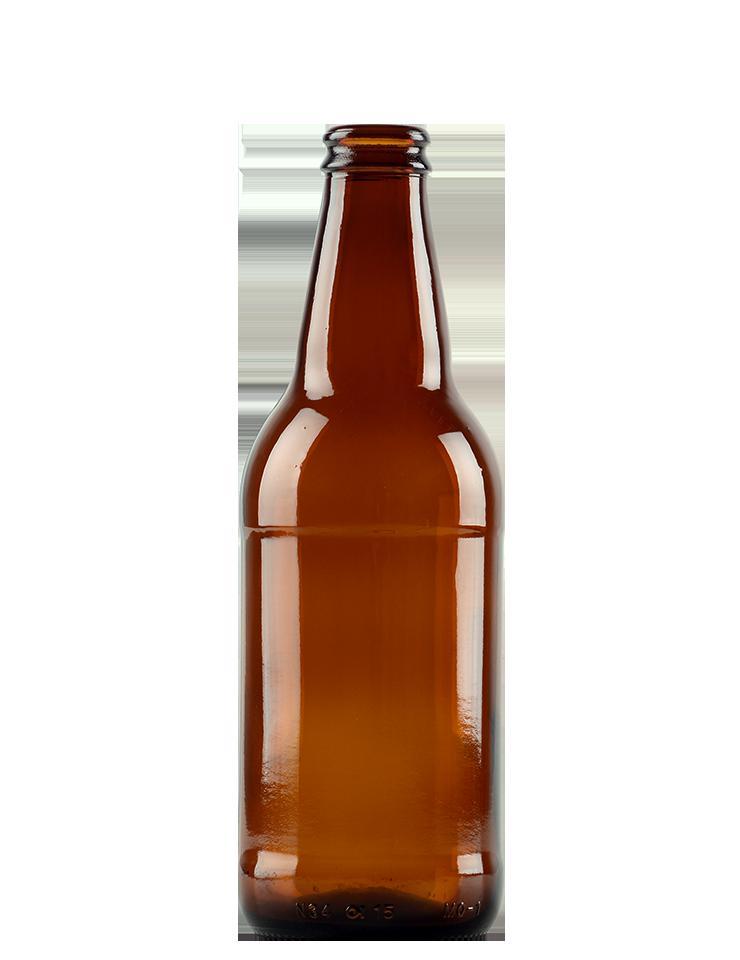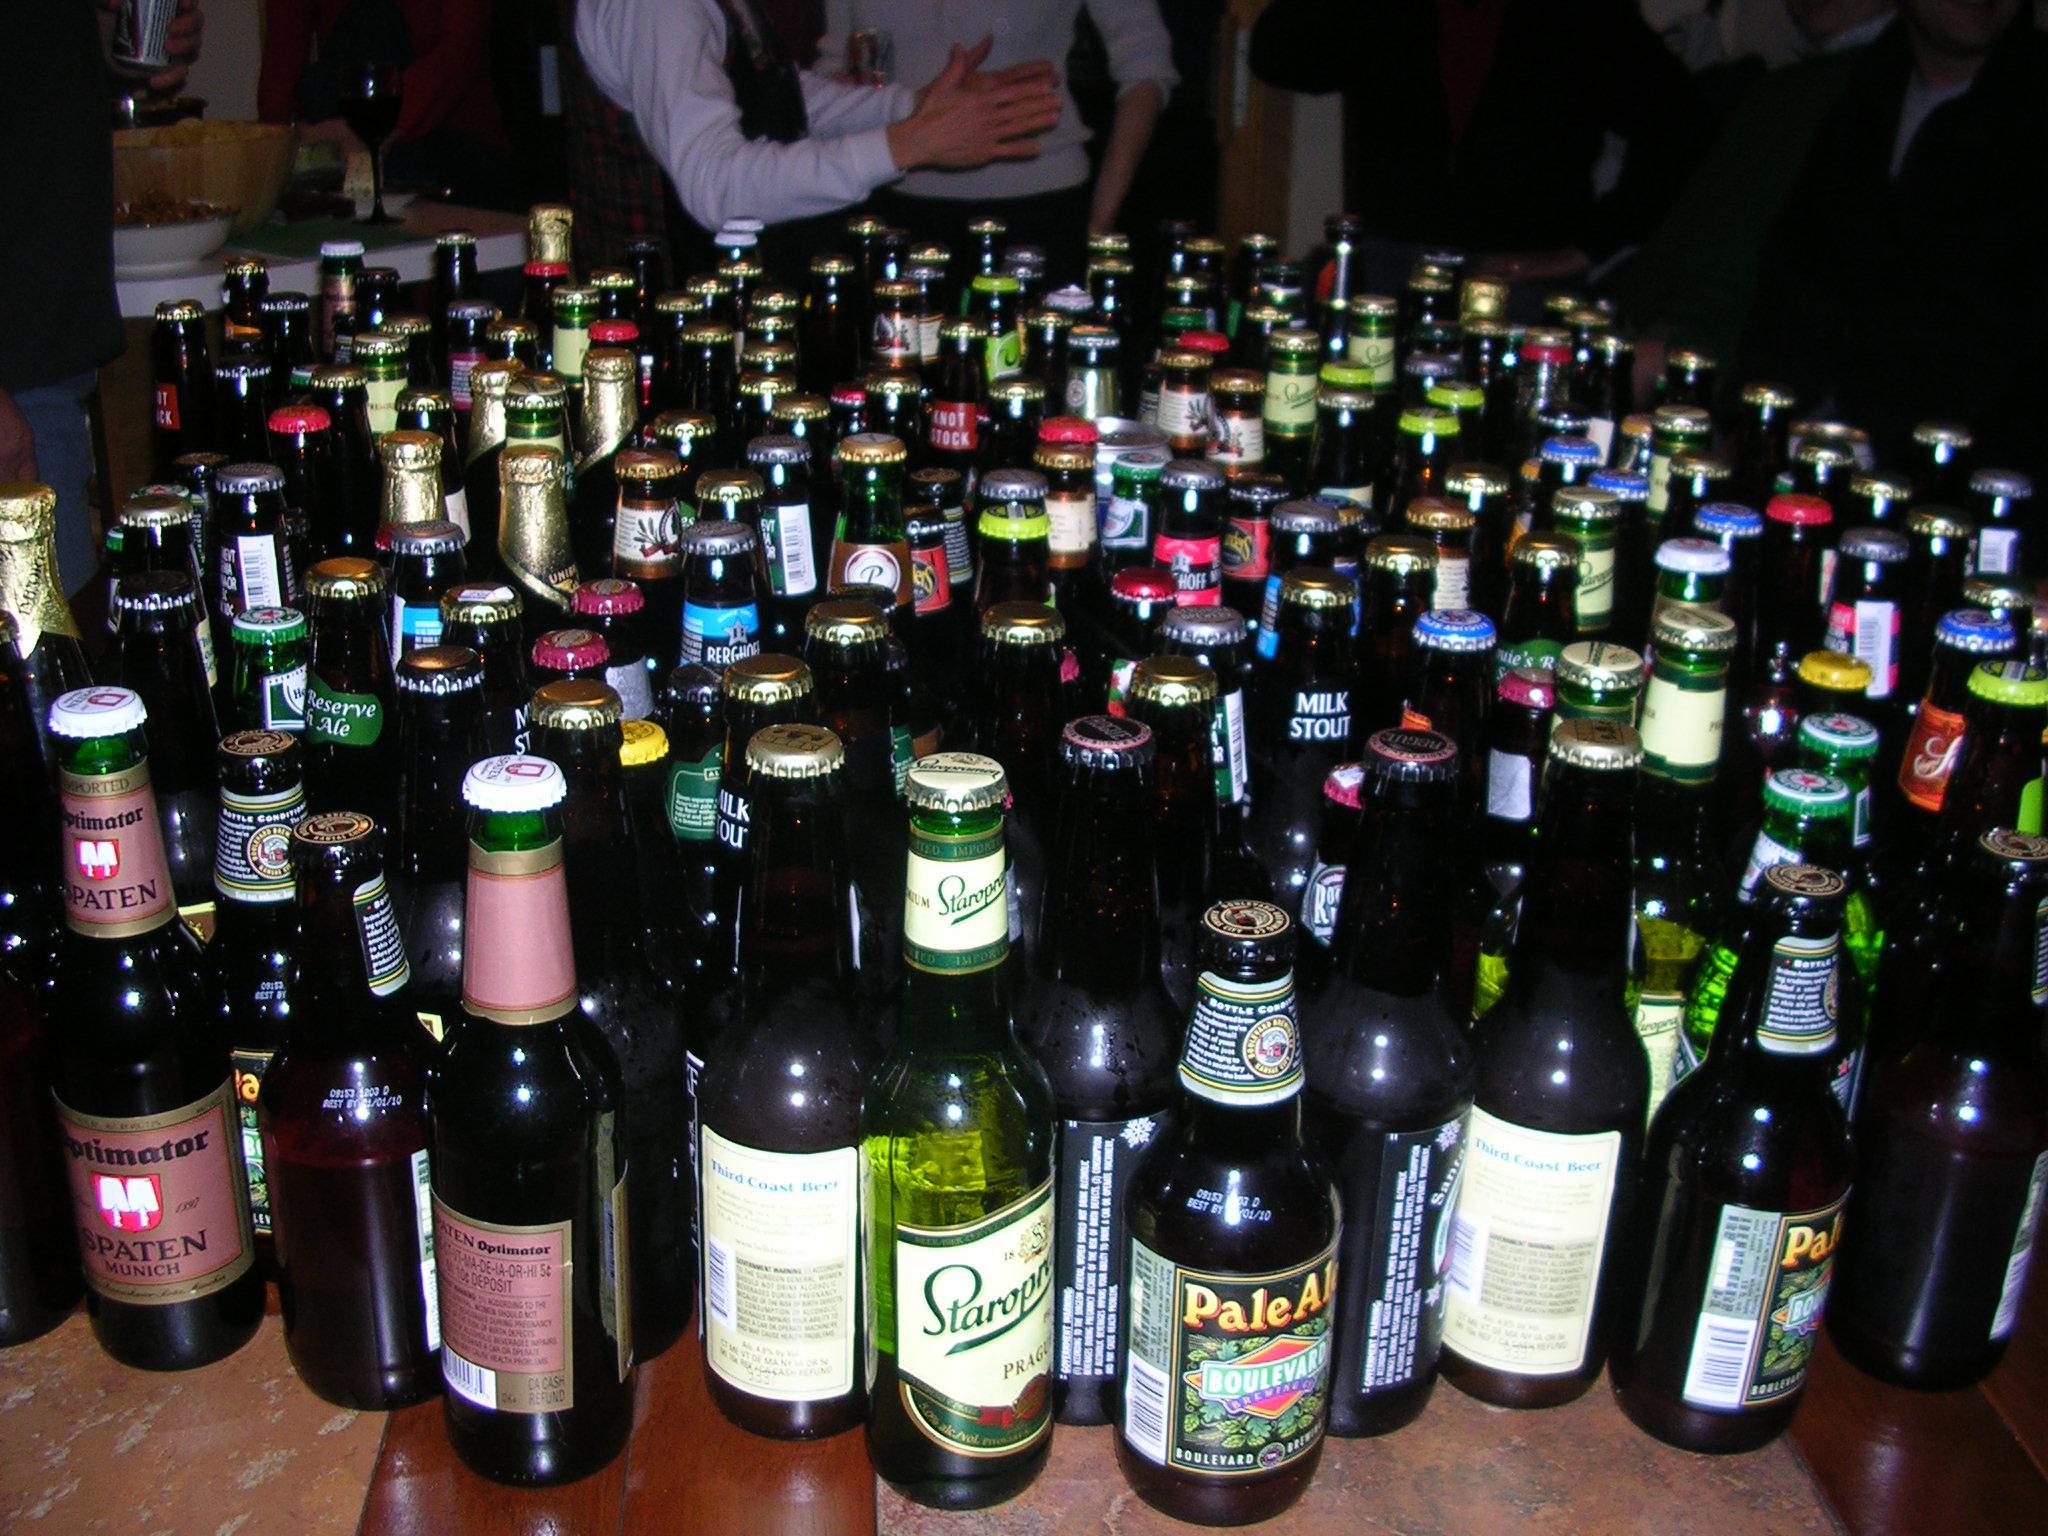The first image is the image on the left, the second image is the image on the right. Examine the images to the left and right. Is the description "One image is a single dark brown glass bottle." accurate? Answer yes or no. Yes. 